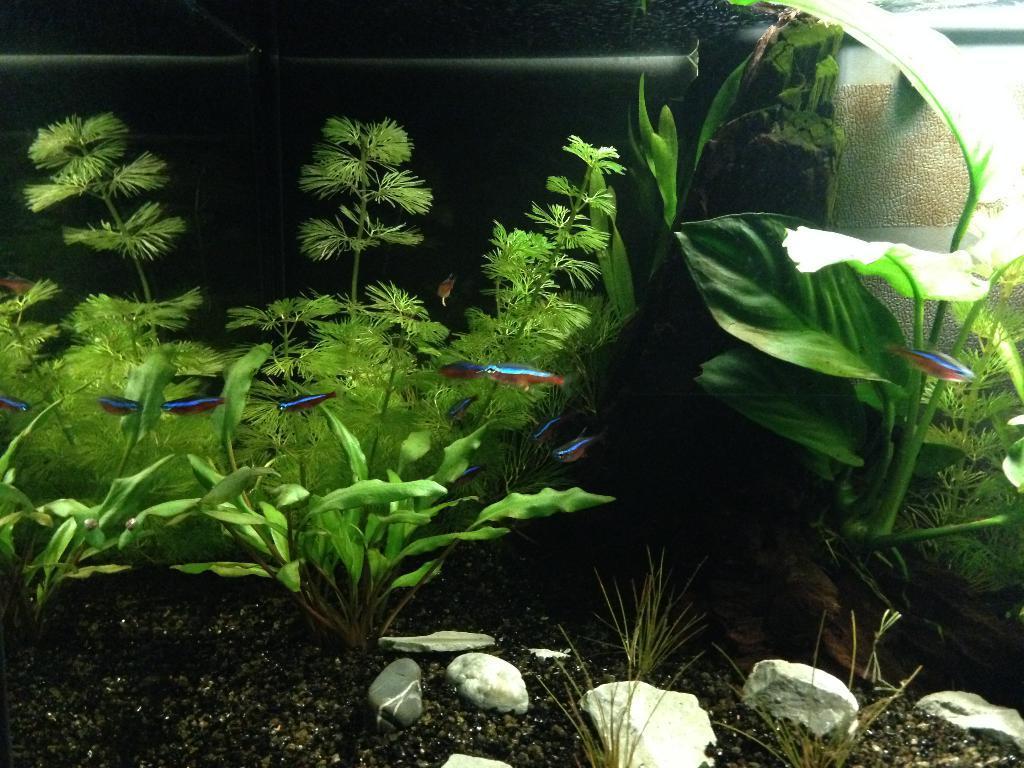How would you summarize this image in a sentence or two? In this image I can see there is a soil and a stone. And there are fishes and plants. And there is a rod in it. And it looks like an aquarium. 